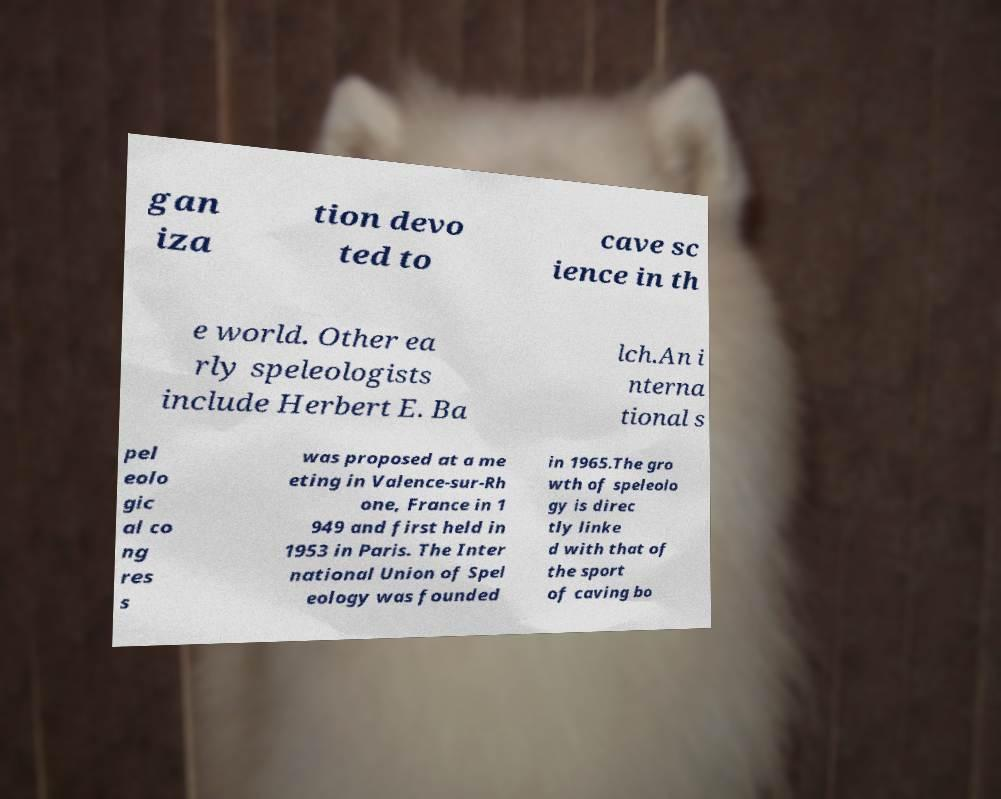What messages or text are displayed in this image? I need them in a readable, typed format. gan iza tion devo ted to cave sc ience in th e world. Other ea rly speleologists include Herbert E. Ba lch.An i nterna tional s pel eolo gic al co ng res s was proposed at a me eting in Valence-sur-Rh one, France in 1 949 and first held in 1953 in Paris. The Inter national Union of Spel eology was founded in 1965.The gro wth of speleolo gy is direc tly linke d with that of the sport of caving bo 